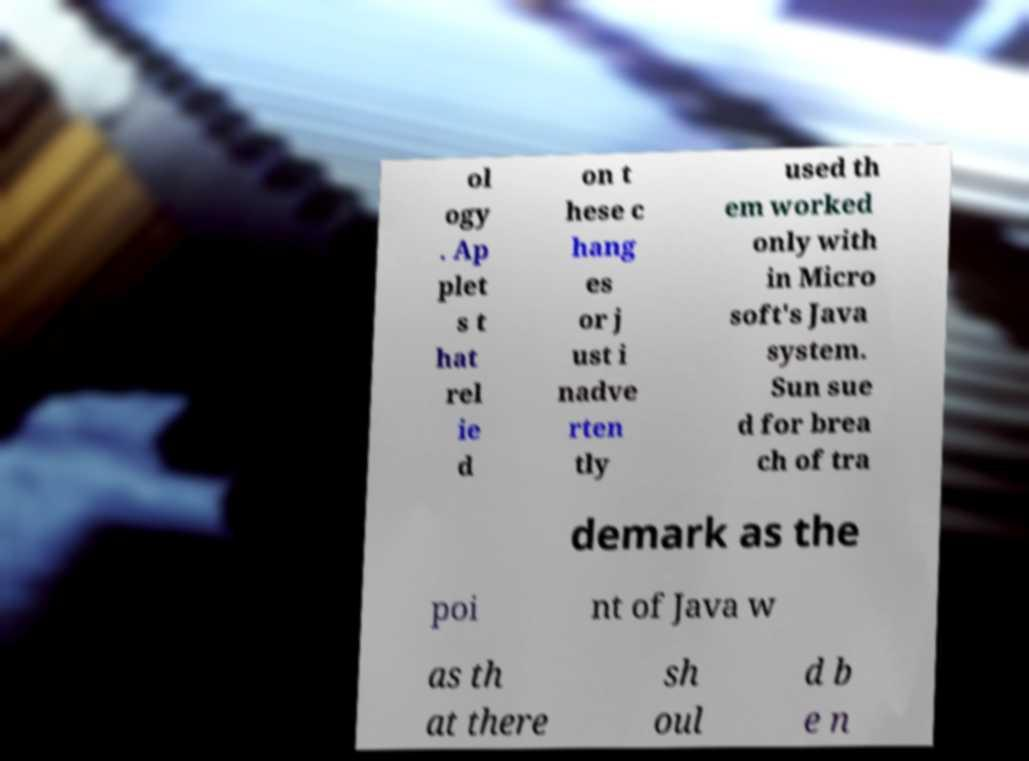Can you read and provide the text displayed in the image?This photo seems to have some interesting text. Can you extract and type it out for me? ol ogy . Ap plet s t hat rel ie d on t hese c hang es or j ust i nadve rten tly used th em worked only with in Micro soft's Java system. Sun sue d for brea ch of tra demark as the poi nt of Java w as th at there sh oul d b e n 